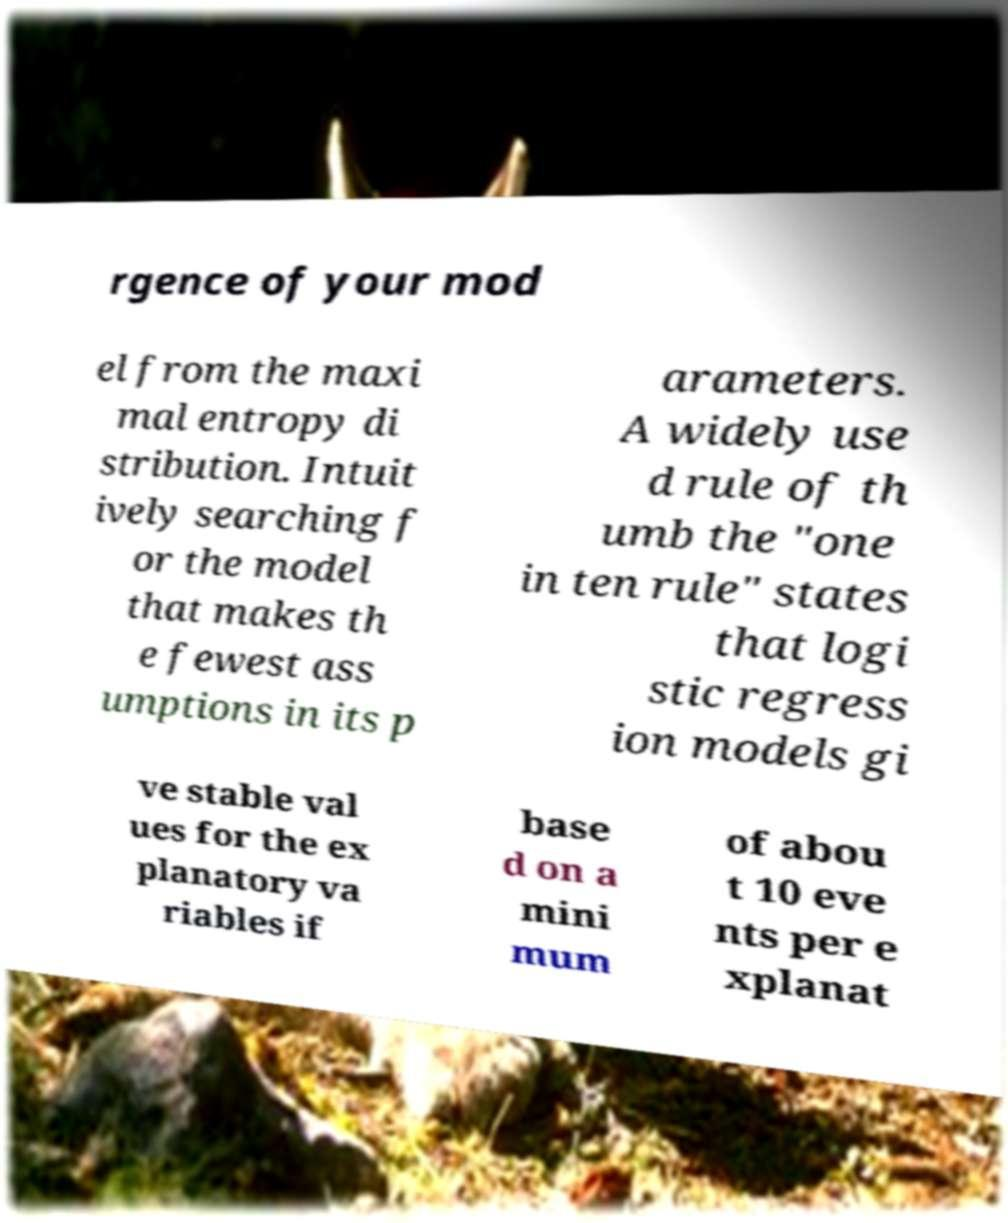Can you read and provide the text displayed in the image?This photo seems to have some interesting text. Can you extract and type it out for me? rgence of your mod el from the maxi mal entropy di stribution. Intuit ively searching f or the model that makes th e fewest ass umptions in its p arameters. A widely use d rule of th umb the "one in ten rule" states that logi stic regress ion models gi ve stable val ues for the ex planatory va riables if base d on a mini mum of abou t 10 eve nts per e xplanat 